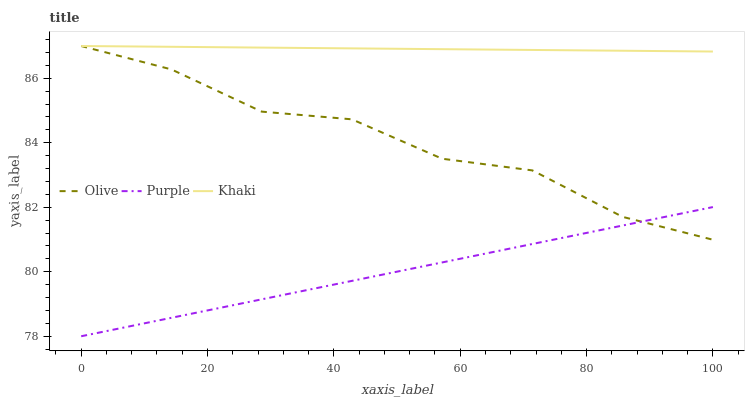Does Purple have the minimum area under the curve?
Answer yes or no. Yes. Does Khaki have the maximum area under the curve?
Answer yes or no. Yes. Does Khaki have the minimum area under the curve?
Answer yes or no. No. Does Purple have the maximum area under the curve?
Answer yes or no. No. Is Purple the smoothest?
Answer yes or no. Yes. Is Olive the roughest?
Answer yes or no. Yes. Is Khaki the smoothest?
Answer yes or no. No. Is Khaki the roughest?
Answer yes or no. No. Does Purple have the lowest value?
Answer yes or no. Yes. Does Khaki have the lowest value?
Answer yes or no. No. Does Khaki have the highest value?
Answer yes or no. Yes. Does Purple have the highest value?
Answer yes or no. No. Is Purple less than Khaki?
Answer yes or no. Yes. Is Khaki greater than Purple?
Answer yes or no. Yes. Does Purple intersect Olive?
Answer yes or no. Yes. Is Purple less than Olive?
Answer yes or no. No. Is Purple greater than Olive?
Answer yes or no. No. Does Purple intersect Khaki?
Answer yes or no. No. 